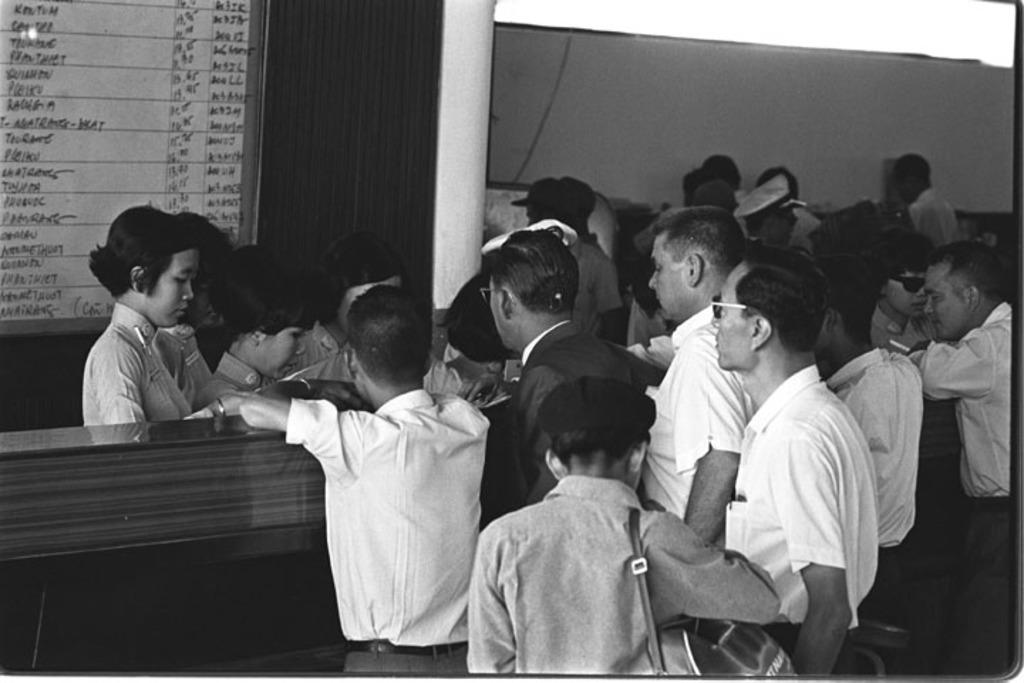What is the color scheme of the image? The image is in black and white. What can be seen in the foreground of the image? There are people in the foreground of the image. What is located in the top left side of the image? There appears to be a board in the top left side of the image. What type of furniture is present in the image? There is a desk in the image. What is blocking the view of the people in the image? There is a pillar in front of the people in the image. What type of juice is being served in the image? There is no juice present in the image. How many balls are visible in the image? There are no balls visible in the image. 